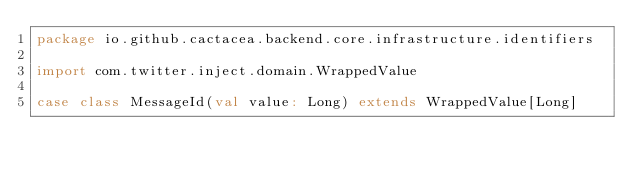Convert code to text. <code><loc_0><loc_0><loc_500><loc_500><_Scala_>package io.github.cactacea.backend.core.infrastructure.identifiers

import com.twitter.inject.domain.WrappedValue

case class MessageId(val value: Long) extends WrappedValue[Long]
</code> 